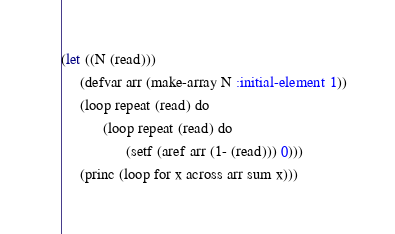<code> <loc_0><loc_0><loc_500><loc_500><_Lisp_>(let ((N (read)))
     (defvar arr (make-array N :initial-element 1))
     (loop repeat (read) do
           (loop repeat (read) do
                 (setf (aref arr (1- (read))) 0)))
     (princ (loop for x across arr sum x)))</code> 